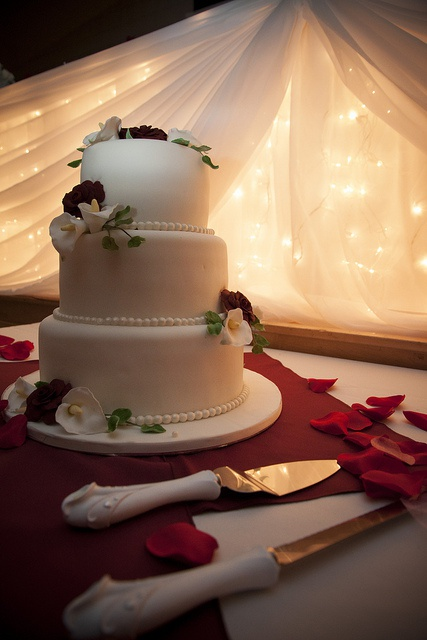Describe the objects in this image and their specific colors. I can see cake in black, gray, and maroon tones, dining table in black, maroon, and gray tones, knife in black, gray, and maroon tones, and knife in black, gray, tan, and maroon tones in this image. 